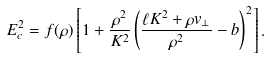Convert formula to latex. <formula><loc_0><loc_0><loc_500><loc_500>E _ { c } ^ { 2 } = f ( \rho ) \left [ 1 + \frac { \rho ^ { 2 } } { K ^ { 2 } } \left ( \frac { \ell K ^ { 2 } + \rho v _ { \perp } } { \rho ^ { 2 } } - { b } \right ) ^ { 2 } \right ] .</formula> 